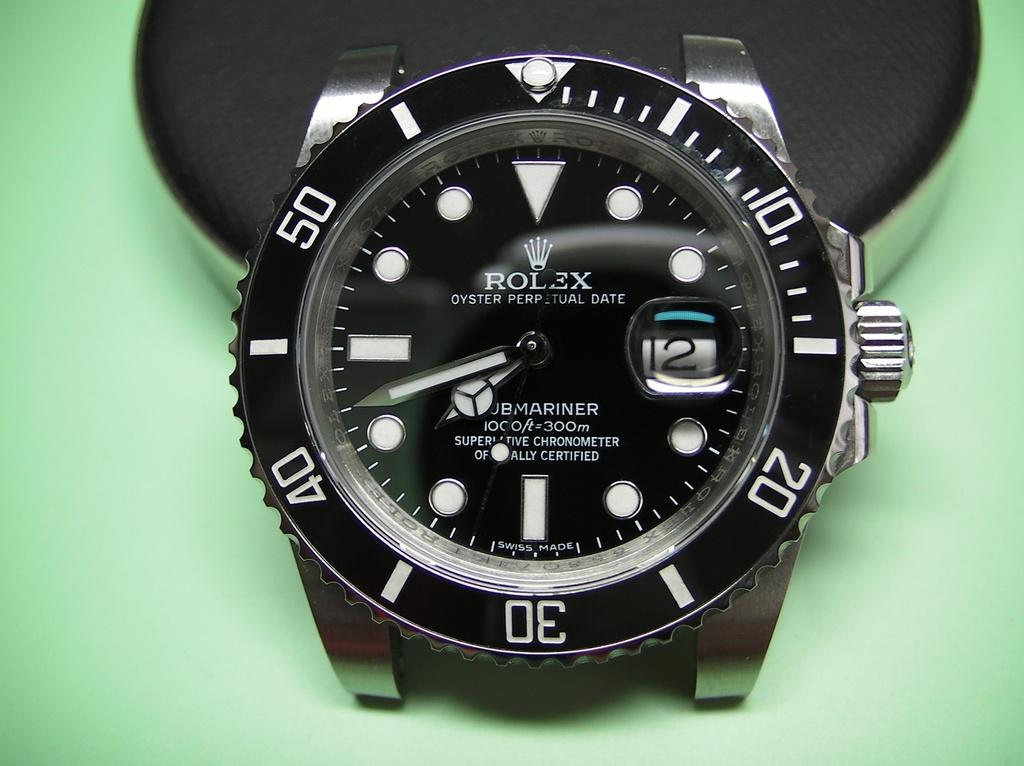<image>
Summarize the visual content of the image. A black Rolex watch that is submariner of 1,000 feet. 